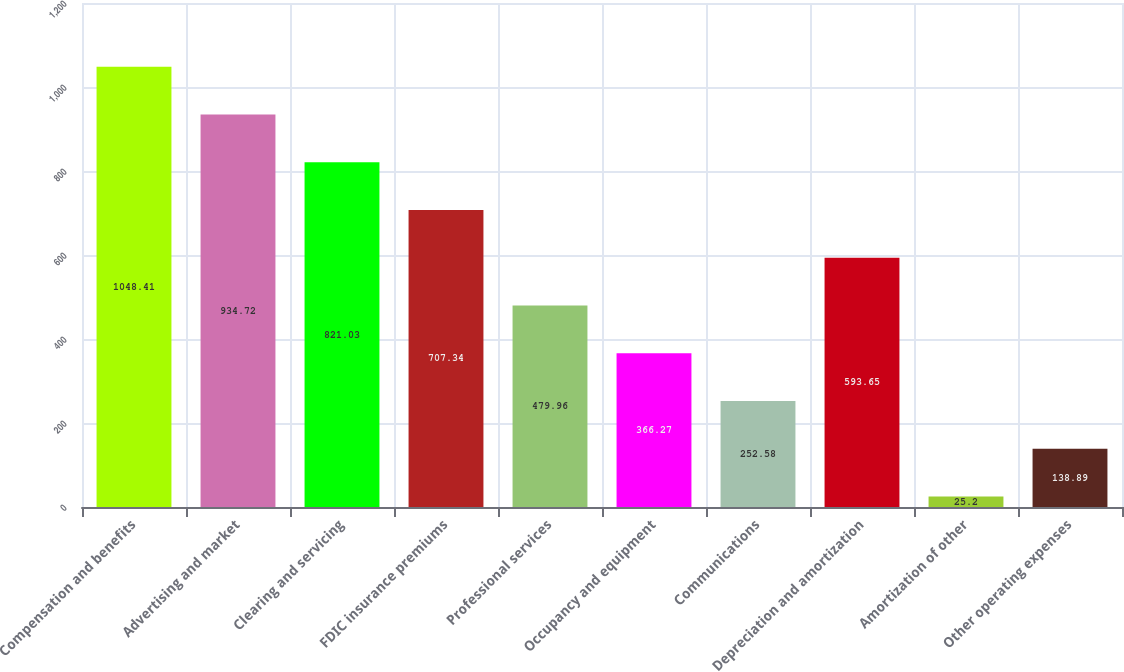<chart> <loc_0><loc_0><loc_500><loc_500><bar_chart><fcel>Compensation and benefits<fcel>Advertising and market<fcel>Clearing and servicing<fcel>FDIC insurance premiums<fcel>Professional services<fcel>Occupancy and equipment<fcel>Communications<fcel>Depreciation and amortization<fcel>Amortization of other<fcel>Other operating expenses<nl><fcel>1048.41<fcel>934.72<fcel>821.03<fcel>707.34<fcel>479.96<fcel>366.27<fcel>252.58<fcel>593.65<fcel>25.2<fcel>138.89<nl></chart> 